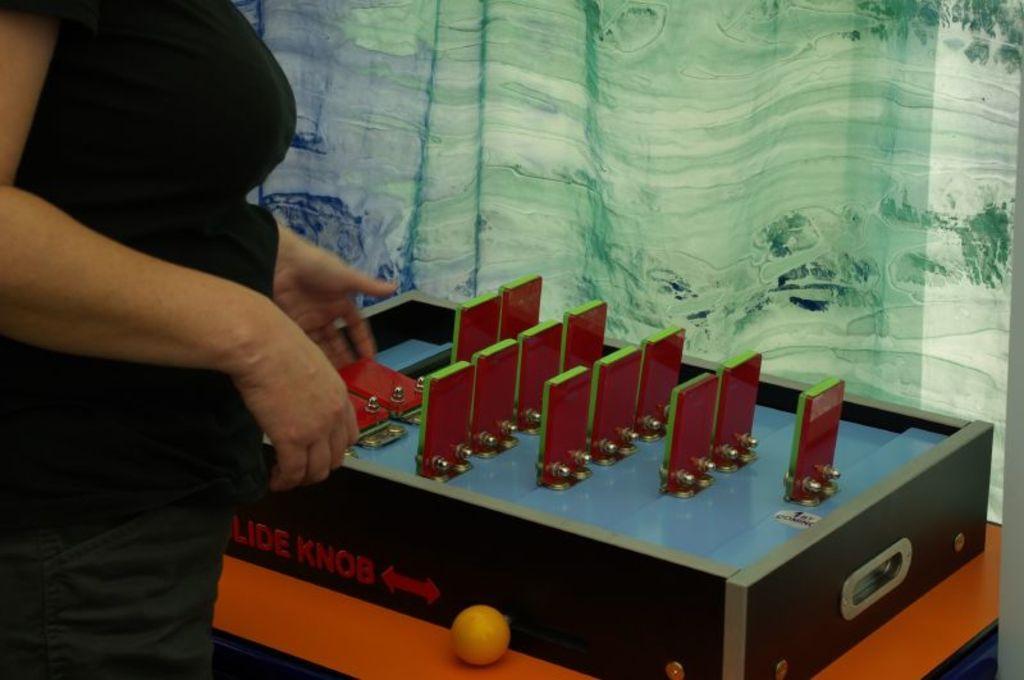How would you summarize this image in a sentence or two? This picture shows a woman standing in front of a table. In the background, there is a curtain here. We can see a ball here on the table. 